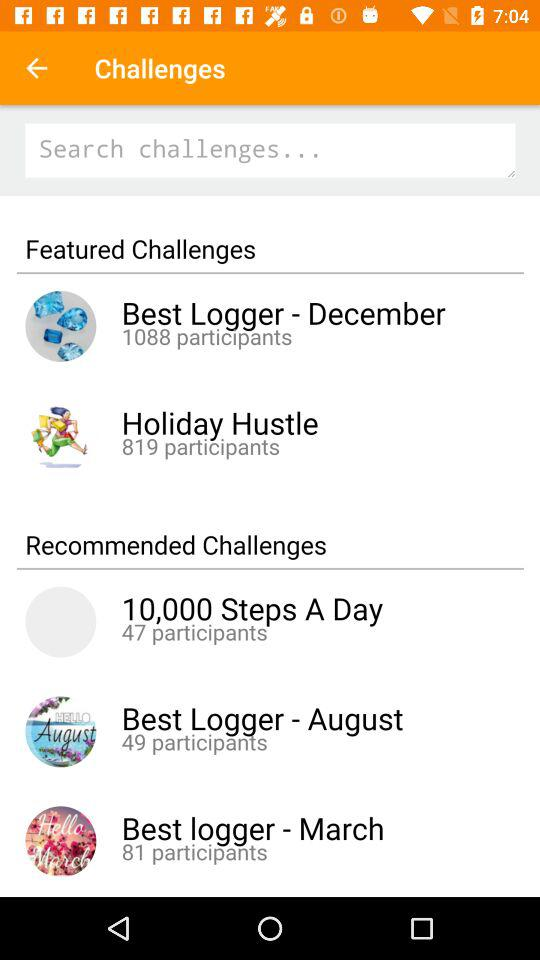Which month is selected for best logger?
When the provided information is insufficient, respond with <no answer>. <no answer> 